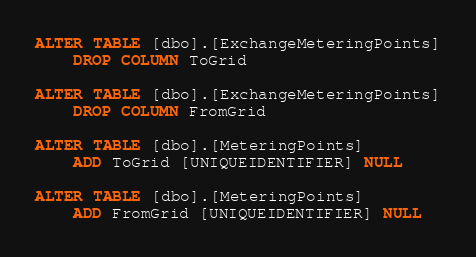Convert code to text. <code><loc_0><loc_0><loc_500><loc_500><_SQL_>ALTER TABLE [dbo].[ExchangeMeteringPoints]
    DROP COLUMN ToGrid

ALTER TABLE [dbo].[ExchangeMeteringPoints]
    DROP COLUMN FromGrid

ALTER TABLE [dbo].[MeteringPoints]
    ADD ToGrid [UNIQUEIDENTIFIER] NULL

ALTER TABLE [dbo].[MeteringPoints]
    ADD FromGrid [UNIQUEIDENTIFIER] NULL</code> 